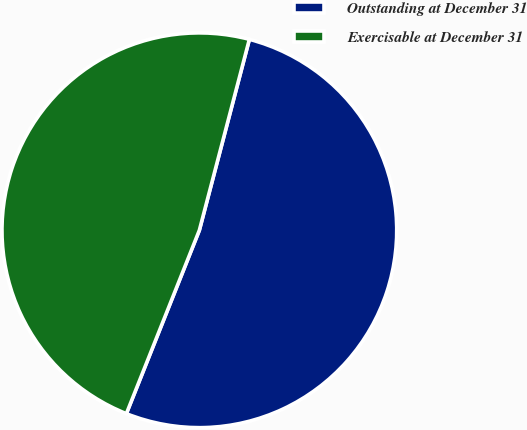Convert chart to OTSL. <chart><loc_0><loc_0><loc_500><loc_500><pie_chart><fcel>Outstanding at December 31<fcel>Exercisable at December 31<nl><fcel>51.95%<fcel>48.05%<nl></chart> 